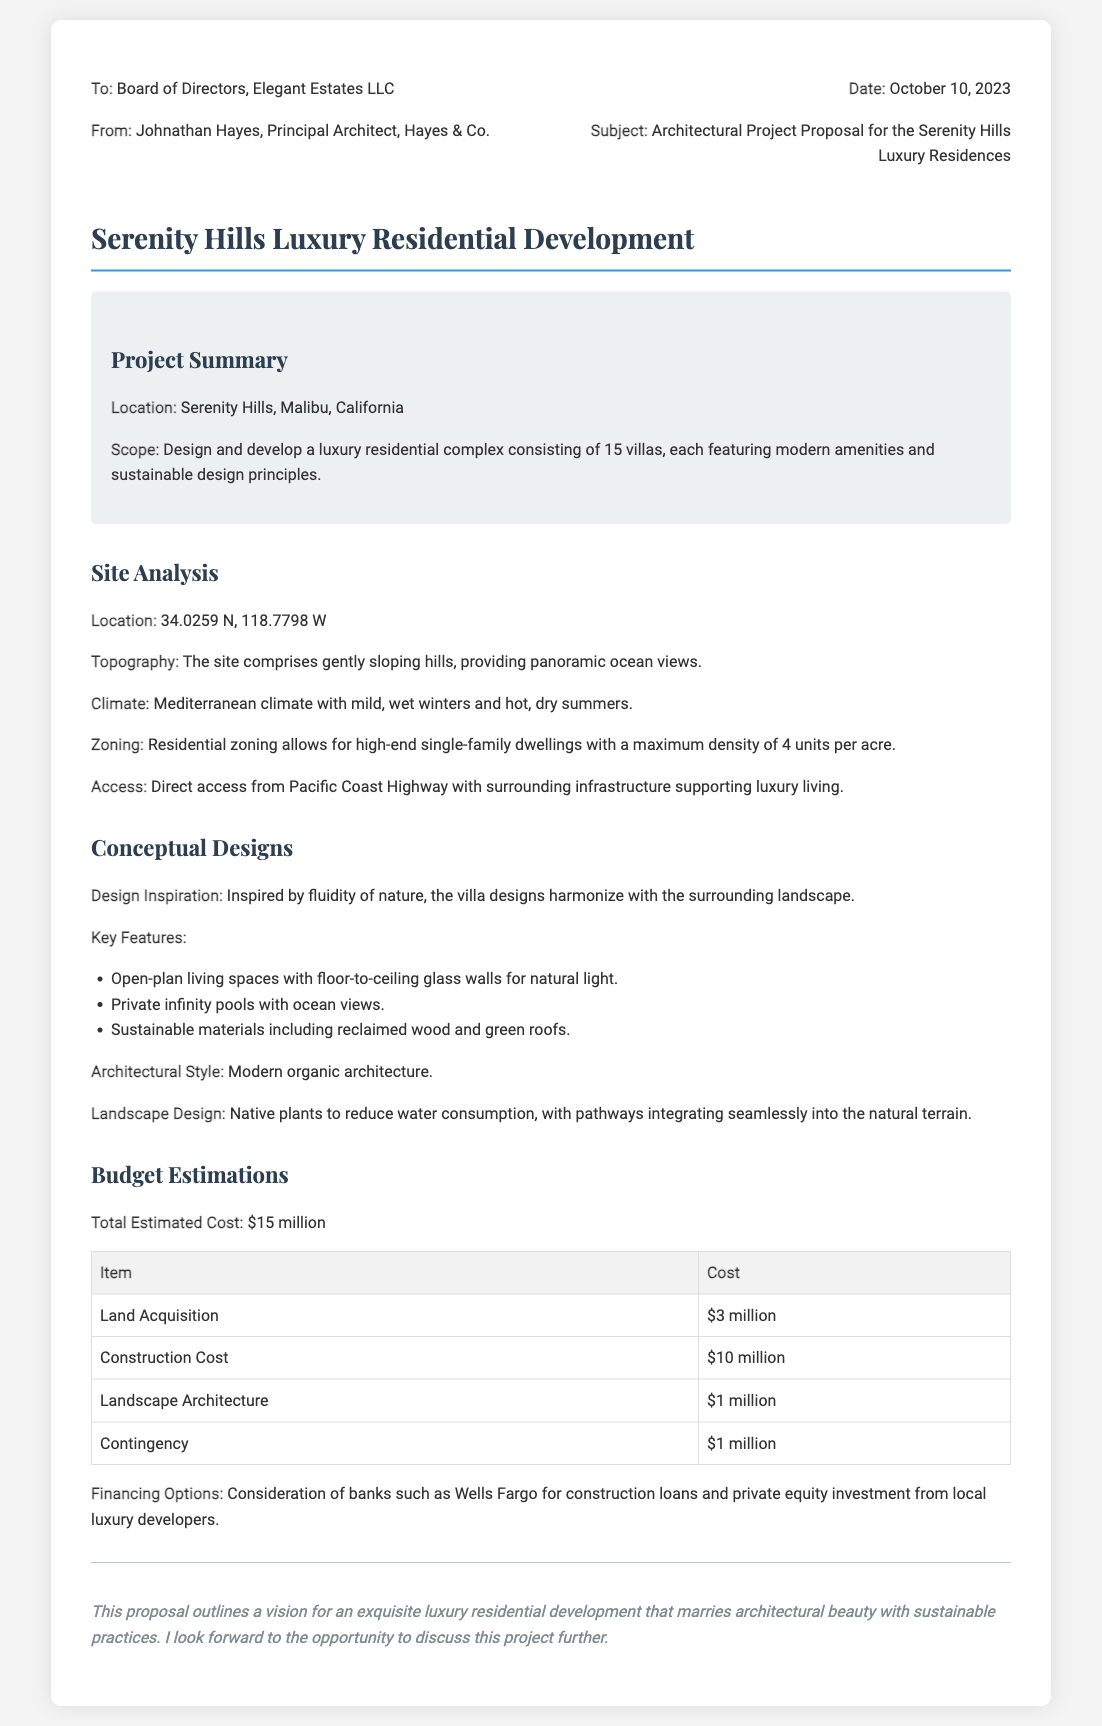What is the location of the project? The location of the project is stated as "Serenity Hills, Malibu, California" in the project summary.
Answer: Serenity Hills, Malibu, California How many villas are proposed in the development? The memo specifies that the luxury residential complex will consist of "15 villas."
Answer: 15 villas What is the total estimated cost for the project? The document explicitly states the total estimated cost as "$15 million."
Answer: $15 million Which architect firm is presenting the proposal? The proposal is presented by "Hayes & Co." and the principal architect is Johnathan Hayes.
Answer: Hayes & Co What type of climate does the site have? The climate description provided in the site analysis states, "Mediterranean climate."
Answer: Mediterranean climate What is one key feature of the villa designs? The key features listed in the conceptual designs include "Open-plan living spaces with floor-to-ceiling glass walls for natural light."
Answer: Open-plan living spaces with floor-to-ceiling glass walls for natural light What is the total cost allocated for landscape architecture? The budget estimations table clearly lists the cost for landscape architecture as "$1 million."
Answer: $1 million How will the project financing be obtained? The proposal mentions "consideration of banks such as Wells Fargo for construction loans."
Answer: Wells Fargo What architectural style is described in the proposal? The document notes that the architectural style is "Modern organic architecture."
Answer: Modern organic architecture 